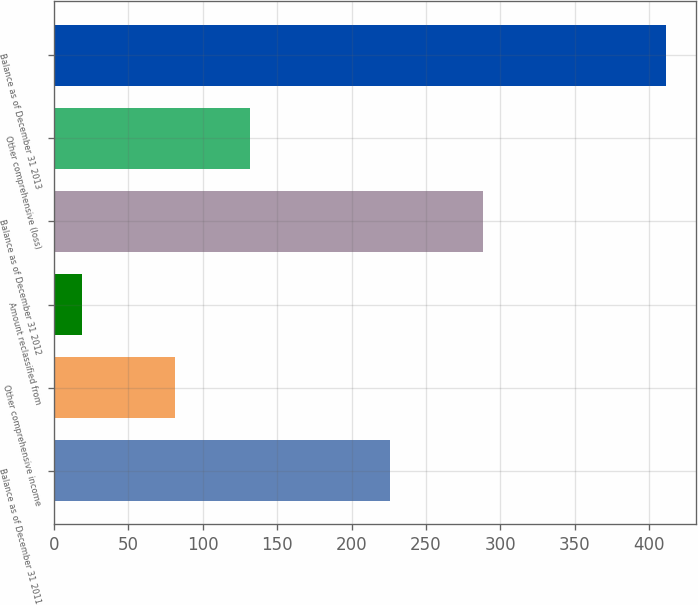<chart> <loc_0><loc_0><loc_500><loc_500><bar_chart><fcel>Balance as of December 31 2011<fcel>Other comprehensive income<fcel>Amount reclassified from<fcel>Balance as of December 31 2012<fcel>Other comprehensive (loss)<fcel>Balance as of December 31 2013<nl><fcel>225.7<fcel>81.3<fcel>19<fcel>288<fcel>131.9<fcel>411.2<nl></chart> 